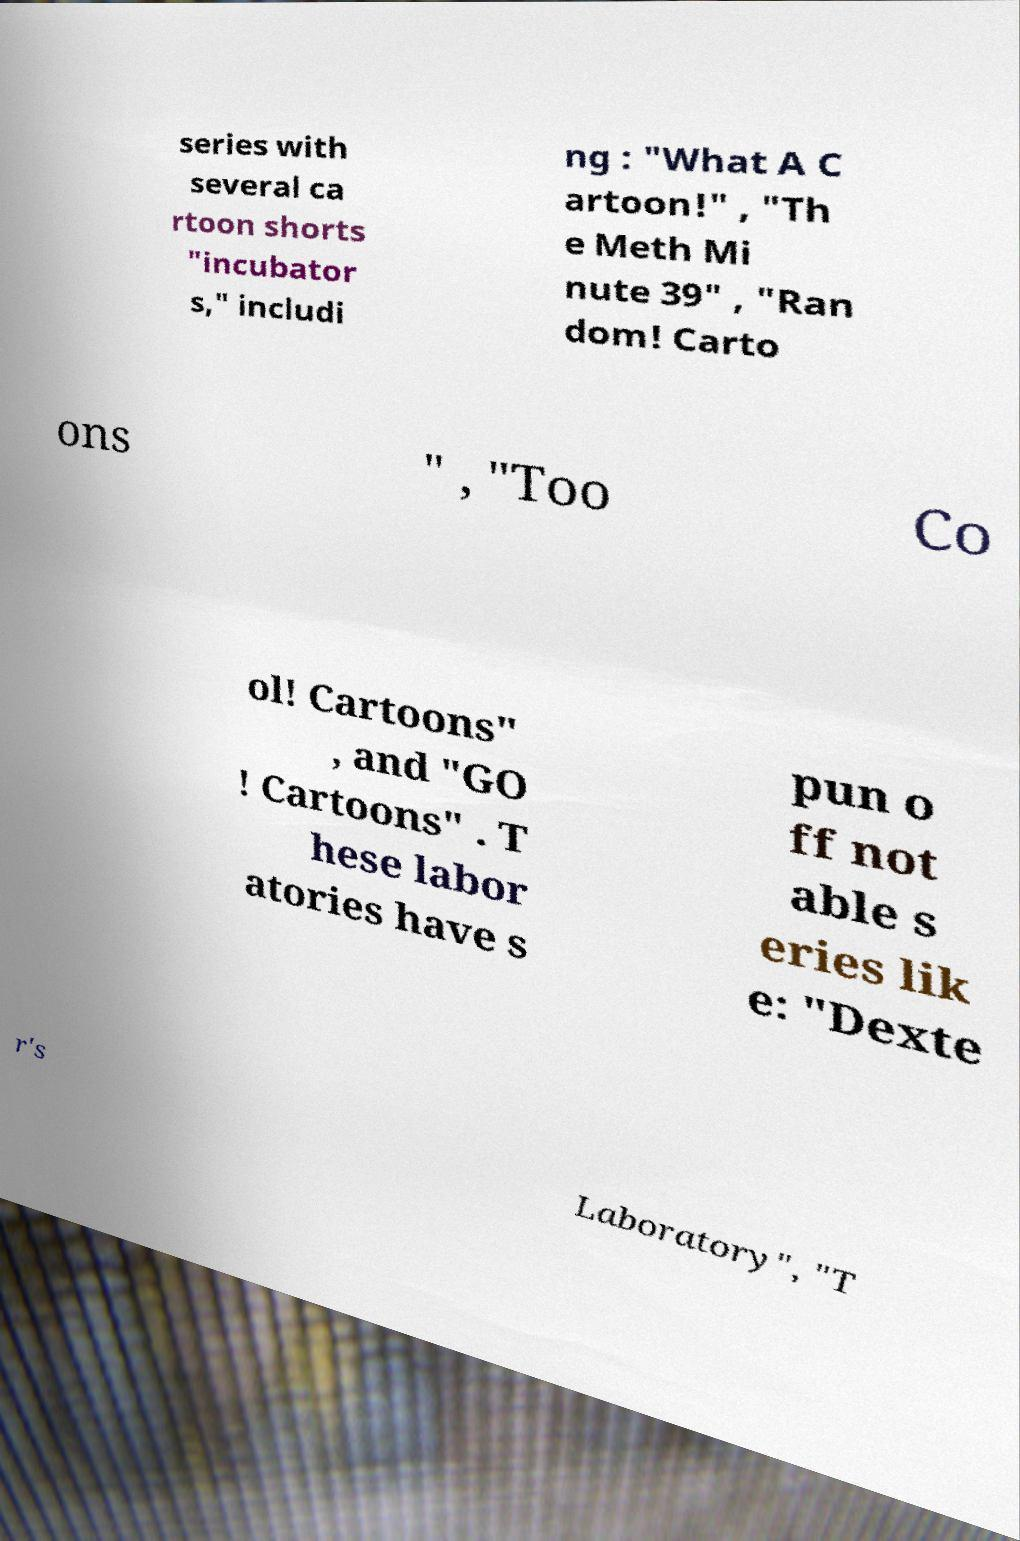Please identify and transcribe the text found in this image. series with several ca rtoon shorts "incubator s," includi ng : "What A C artoon!" , "Th e Meth Mi nute 39" , "Ran dom! Carto ons " , "Too Co ol! Cartoons" , and "GO ! Cartoons" . T hese labor atories have s pun o ff not able s eries lik e: "Dexte r's Laboratory", "T 